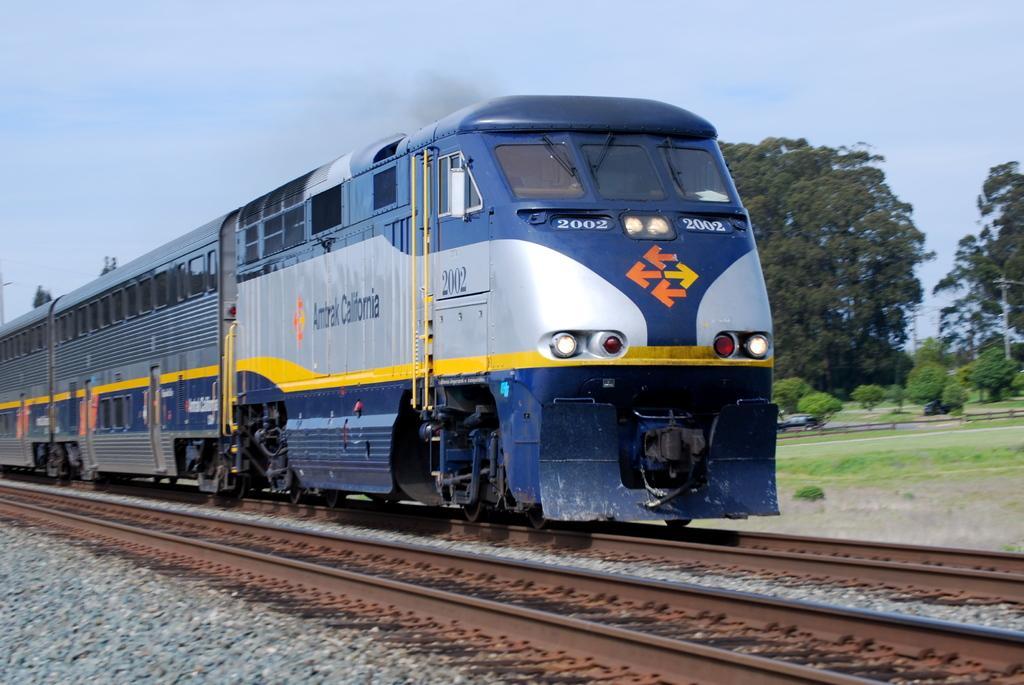How would you summarize this image in a sentence or two? In this image there are train tracks, a train is moving on a track, in the background there are trees and a sky. 